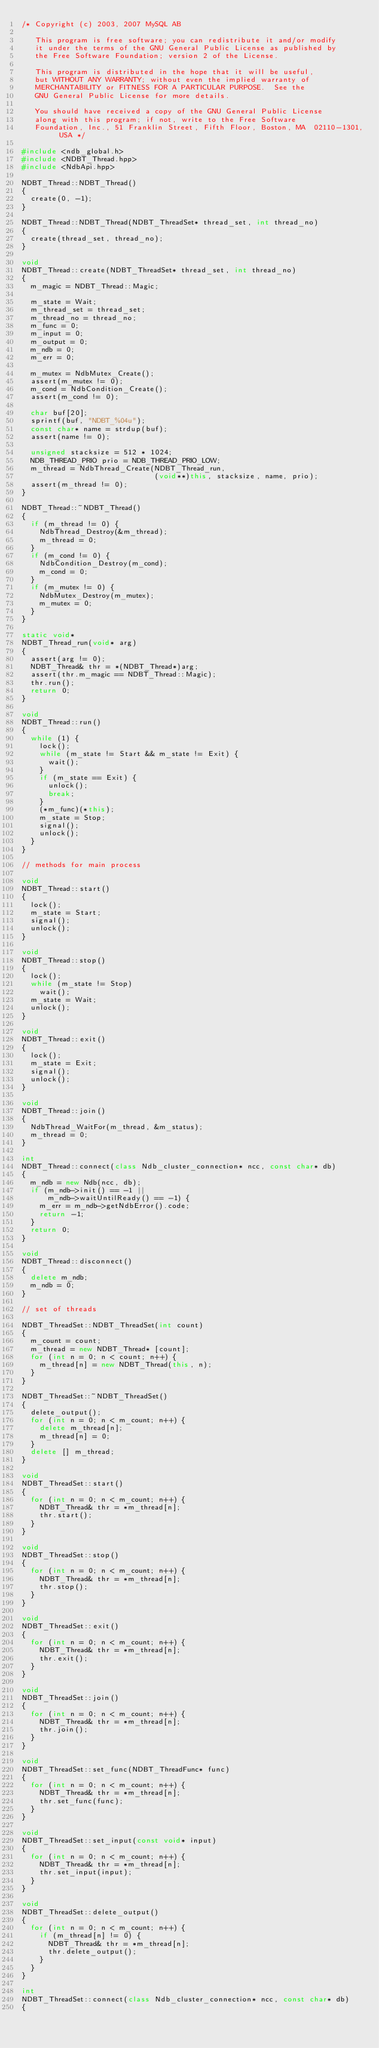<code> <loc_0><loc_0><loc_500><loc_500><_C++_>/* Copyright (c) 2003, 2007 MySQL AB

   This program is free software; you can redistribute it and/or modify
   it under the terms of the GNU General Public License as published by
   the Free Software Foundation; version 2 of the License.

   This program is distributed in the hope that it will be useful,
   but WITHOUT ANY WARRANTY; without even the implied warranty of
   MERCHANTABILITY or FITNESS FOR A PARTICULAR PURPOSE.  See the
   GNU General Public License for more details.

   You should have received a copy of the GNU General Public License
   along with this program; if not, write to the Free Software
   Foundation, Inc., 51 Franklin Street, Fifth Floor, Boston, MA  02110-1301, USA */

#include <ndb_global.h>
#include <NDBT_Thread.hpp>
#include <NdbApi.hpp>

NDBT_Thread::NDBT_Thread()
{
  create(0, -1);
}

NDBT_Thread::NDBT_Thread(NDBT_ThreadSet* thread_set, int thread_no)
{
  create(thread_set, thread_no);
}

void
NDBT_Thread::create(NDBT_ThreadSet* thread_set, int thread_no)
{
  m_magic = NDBT_Thread::Magic;

  m_state = Wait;
  m_thread_set = thread_set;
  m_thread_no = thread_no;
  m_func = 0;
  m_input = 0;
  m_output = 0;
  m_ndb = 0;
  m_err = 0;

  m_mutex = NdbMutex_Create();
  assert(m_mutex != 0);
  m_cond = NdbCondition_Create();
  assert(m_cond != 0);

  char buf[20];
  sprintf(buf, "NDBT_%04u");
  const char* name = strdup(buf);
  assert(name != 0);

  unsigned stacksize = 512 * 1024;
  NDB_THREAD_PRIO prio = NDB_THREAD_PRIO_LOW;
  m_thread = NdbThread_Create(NDBT_Thread_run,
                              (void**)this, stacksize, name, prio);
  assert(m_thread != 0);
}

NDBT_Thread::~NDBT_Thread()
{
  if (m_thread != 0) {
    NdbThread_Destroy(&m_thread);
    m_thread = 0;
  }
  if (m_cond != 0) {
    NdbCondition_Destroy(m_cond);
    m_cond = 0;
  }
  if (m_mutex != 0) {
    NdbMutex_Destroy(m_mutex);
    m_mutex = 0;
  }
}

static void*
NDBT_Thread_run(void* arg)
{
  assert(arg != 0);
  NDBT_Thread& thr = *(NDBT_Thread*)arg;
  assert(thr.m_magic == NDBT_Thread::Magic);
  thr.run();
  return 0;
}

void
NDBT_Thread::run()
{
  while (1) {
    lock();
    while (m_state != Start && m_state != Exit) {
      wait();
    }
    if (m_state == Exit) {
      unlock();
      break;
    }
    (*m_func)(*this);
    m_state = Stop;
    signal();
    unlock();
  }
}

// methods for main process

void
NDBT_Thread::start()
{
  lock();
  m_state = Start;
  signal();
  unlock();
}

void
NDBT_Thread::stop()
{
  lock();
  while (m_state != Stop)
    wait();
  m_state = Wait;
  unlock();
}

void
NDBT_Thread::exit()
{
  lock();
  m_state = Exit;
  signal();
  unlock();
}

void
NDBT_Thread::join()
{
  NdbThread_WaitFor(m_thread, &m_status);
  m_thread = 0;
}

int
NDBT_Thread::connect(class Ndb_cluster_connection* ncc, const char* db)
{
  m_ndb = new Ndb(ncc, db);
  if (m_ndb->init() == -1 ||
      m_ndb->waitUntilReady() == -1) {
    m_err = m_ndb->getNdbError().code;
    return -1;
  }
  return 0;
}

void
NDBT_Thread::disconnect()
{
  delete m_ndb;
  m_ndb = 0;
}

// set of threads

NDBT_ThreadSet::NDBT_ThreadSet(int count)
{
  m_count = count;
  m_thread = new NDBT_Thread* [count];
  for (int n = 0; n < count; n++) {
    m_thread[n] = new NDBT_Thread(this, n);
  }
}

NDBT_ThreadSet::~NDBT_ThreadSet()
{
  delete_output();
  for (int n = 0; n < m_count; n++) {
    delete m_thread[n];
    m_thread[n] = 0;
  }
  delete [] m_thread;
}

void
NDBT_ThreadSet::start()
{
  for (int n = 0; n < m_count; n++) {
    NDBT_Thread& thr = *m_thread[n];
    thr.start();
  }
}

void
NDBT_ThreadSet::stop()
{
  for (int n = 0; n < m_count; n++) {
    NDBT_Thread& thr = *m_thread[n];
    thr.stop();
  }
}

void
NDBT_ThreadSet::exit()
{
  for (int n = 0; n < m_count; n++) {
    NDBT_Thread& thr = *m_thread[n];
    thr.exit();
  }
}

void
NDBT_ThreadSet::join()
{
  for (int n = 0; n < m_count; n++) {
    NDBT_Thread& thr = *m_thread[n];
    thr.join();
  }
}

void
NDBT_ThreadSet::set_func(NDBT_ThreadFunc* func)
{
  for (int n = 0; n < m_count; n++) {
    NDBT_Thread& thr = *m_thread[n];
    thr.set_func(func);
  }
}

void
NDBT_ThreadSet::set_input(const void* input)
{
  for (int n = 0; n < m_count; n++) {
    NDBT_Thread& thr = *m_thread[n];
    thr.set_input(input);
  }
}

void
NDBT_ThreadSet::delete_output()
{
  for (int n = 0; n < m_count; n++) {
    if (m_thread[n] != 0) {
      NDBT_Thread& thr = *m_thread[n];
      thr.delete_output();
    }
  }
}

int
NDBT_ThreadSet::connect(class Ndb_cluster_connection* ncc, const char* db)
{</code> 